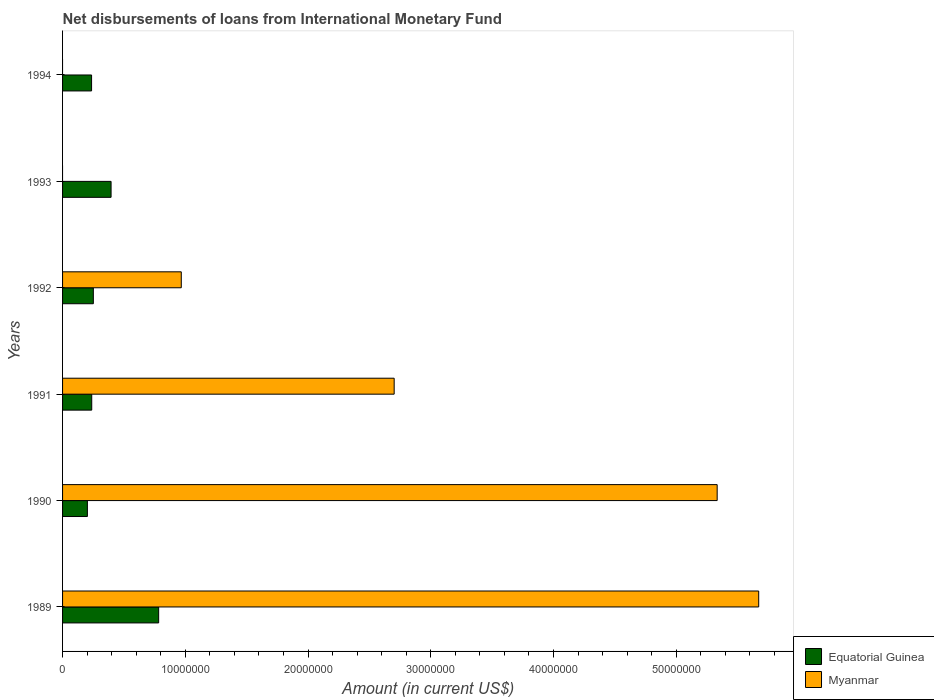How many different coloured bars are there?
Offer a terse response. 2. Are the number of bars per tick equal to the number of legend labels?
Your answer should be very brief. No. Are the number of bars on each tick of the Y-axis equal?
Offer a terse response. No. How many bars are there on the 3rd tick from the bottom?
Offer a very short reply. 2. What is the amount of loans disbursed in Myanmar in 1989?
Your answer should be very brief. 5.67e+07. Across all years, what is the maximum amount of loans disbursed in Myanmar?
Your response must be concise. 5.67e+07. Across all years, what is the minimum amount of loans disbursed in Myanmar?
Offer a terse response. 0. In which year was the amount of loans disbursed in Equatorial Guinea maximum?
Offer a very short reply. 1989. What is the total amount of loans disbursed in Equatorial Guinea in the graph?
Make the answer very short. 2.11e+07. What is the difference between the amount of loans disbursed in Equatorial Guinea in 1990 and that in 1991?
Offer a terse response. -3.53e+05. What is the difference between the amount of loans disbursed in Myanmar in 1994 and the amount of loans disbursed in Equatorial Guinea in 1989?
Your response must be concise. -7.83e+06. What is the average amount of loans disbursed in Equatorial Guinea per year?
Your answer should be compact. 3.51e+06. In the year 1992, what is the difference between the amount of loans disbursed in Myanmar and amount of loans disbursed in Equatorial Guinea?
Your response must be concise. 7.17e+06. What is the ratio of the amount of loans disbursed in Myanmar in 1990 to that in 1992?
Offer a very short reply. 5.51. Is the amount of loans disbursed in Equatorial Guinea in 1990 less than that in 1992?
Offer a very short reply. Yes. What is the difference between the highest and the second highest amount of loans disbursed in Equatorial Guinea?
Your answer should be very brief. 3.88e+06. What is the difference between the highest and the lowest amount of loans disbursed in Equatorial Guinea?
Offer a very short reply. 5.81e+06. Is the sum of the amount of loans disbursed in Equatorial Guinea in 1990 and 1994 greater than the maximum amount of loans disbursed in Myanmar across all years?
Give a very brief answer. No. How many years are there in the graph?
Your answer should be compact. 6. Does the graph contain grids?
Keep it short and to the point. No. How many legend labels are there?
Provide a succinct answer. 2. What is the title of the graph?
Provide a succinct answer. Net disbursements of loans from International Monetary Fund. What is the label or title of the Y-axis?
Make the answer very short. Years. What is the Amount (in current US$) of Equatorial Guinea in 1989?
Make the answer very short. 7.83e+06. What is the Amount (in current US$) in Myanmar in 1989?
Your answer should be compact. 5.67e+07. What is the Amount (in current US$) in Equatorial Guinea in 1990?
Provide a short and direct response. 2.02e+06. What is the Amount (in current US$) of Myanmar in 1990?
Ensure brevity in your answer.  5.33e+07. What is the Amount (in current US$) of Equatorial Guinea in 1991?
Provide a succinct answer. 2.38e+06. What is the Amount (in current US$) in Myanmar in 1991?
Your answer should be compact. 2.70e+07. What is the Amount (in current US$) in Equatorial Guinea in 1992?
Your response must be concise. 2.51e+06. What is the Amount (in current US$) of Myanmar in 1992?
Your answer should be compact. 9.67e+06. What is the Amount (in current US$) of Equatorial Guinea in 1993?
Keep it short and to the point. 3.95e+06. What is the Amount (in current US$) of Equatorial Guinea in 1994?
Give a very brief answer. 2.36e+06. Across all years, what is the maximum Amount (in current US$) of Equatorial Guinea?
Offer a terse response. 7.83e+06. Across all years, what is the maximum Amount (in current US$) in Myanmar?
Make the answer very short. 5.67e+07. Across all years, what is the minimum Amount (in current US$) in Equatorial Guinea?
Keep it short and to the point. 2.02e+06. Across all years, what is the minimum Amount (in current US$) in Myanmar?
Your response must be concise. 0. What is the total Amount (in current US$) in Equatorial Guinea in the graph?
Offer a terse response. 2.11e+07. What is the total Amount (in current US$) of Myanmar in the graph?
Your response must be concise. 1.47e+08. What is the difference between the Amount (in current US$) in Equatorial Guinea in 1989 and that in 1990?
Offer a very short reply. 5.81e+06. What is the difference between the Amount (in current US$) in Myanmar in 1989 and that in 1990?
Provide a short and direct response. 3.38e+06. What is the difference between the Amount (in current US$) of Equatorial Guinea in 1989 and that in 1991?
Offer a terse response. 5.45e+06. What is the difference between the Amount (in current US$) in Myanmar in 1989 and that in 1991?
Provide a succinct answer. 2.97e+07. What is the difference between the Amount (in current US$) of Equatorial Guinea in 1989 and that in 1992?
Provide a succinct answer. 5.32e+06. What is the difference between the Amount (in current US$) of Myanmar in 1989 and that in 1992?
Your answer should be very brief. 4.70e+07. What is the difference between the Amount (in current US$) in Equatorial Guinea in 1989 and that in 1993?
Offer a terse response. 3.88e+06. What is the difference between the Amount (in current US$) in Equatorial Guinea in 1989 and that in 1994?
Offer a very short reply. 5.47e+06. What is the difference between the Amount (in current US$) of Equatorial Guinea in 1990 and that in 1991?
Offer a very short reply. -3.53e+05. What is the difference between the Amount (in current US$) in Myanmar in 1990 and that in 1991?
Keep it short and to the point. 2.63e+07. What is the difference between the Amount (in current US$) in Equatorial Guinea in 1990 and that in 1992?
Your answer should be compact. -4.84e+05. What is the difference between the Amount (in current US$) in Myanmar in 1990 and that in 1992?
Ensure brevity in your answer.  4.37e+07. What is the difference between the Amount (in current US$) of Equatorial Guinea in 1990 and that in 1993?
Your response must be concise. -1.93e+06. What is the difference between the Amount (in current US$) in Equatorial Guinea in 1990 and that in 1994?
Provide a short and direct response. -3.40e+05. What is the difference between the Amount (in current US$) in Equatorial Guinea in 1991 and that in 1992?
Your answer should be very brief. -1.31e+05. What is the difference between the Amount (in current US$) of Myanmar in 1991 and that in 1992?
Offer a terse response. 1.73e+07. What is the difference between the Amount (in current US$) of Equatorial Guinea in 1991 and that in 1993?
Your answer should be very brief. -1.58e+06. What is the difference between the Amount (in current US$) in Equatorial Guinea in 1991 and that in 1994?
Offer a terse response. 1.27e+04. What is the difference between the Amount (in current US$) in Equatorial Guinea in 1992 and that in 1993?
Provide a succinct answer. -1.45e+06. What is the difference between the Amount (in current US$) of Equatorial Guinea in 1992 and that in 1994?
Make the answer very short. 1.44e+05. What is the difference between the Amount (in current US$) in Equatorial Guinea in 1993 and that in 1994?
Offer a very short reply. 1.59e+06. What is the difference between the Amount (in current US$) of Equatorial Guinea in 1989 and the Amount (in current US$) of Myanmar in 1990?
Provide a succinct answer. -4.55e+07. What is the difference between the Amount (in current US$) of Equatorial Guinea in 1989 and the Amount (in current US$) of Myanmar in 1991?
Your answer should be very brief. -1.92e+07. What is the difference between the Amount (in current US$) of Equatorial Guinea in 1989 and the Amount (in current US$) of Myanmar in 1992?
Your answer should be compact. -1.84e+06. What is the difference between the Amount (in current US$) of Equatorial Guinea in 1990 and the Amount (in current US$) of Myanmar in 1991?
Offer a terse response. -2.50e+07. What is the difference between the Amount (in current US$) in Equatorial Guinea in 1990 and the Amount (in current US$) in Myanmar in 1992?
Make the answer very short. -7.65e+06. What is the difference between the Amount (in current US$) of Equatorial Guinea in 1991 and the Amount (in current US$) of Myanmar in 1992?
Your answer should be compact. -7.30e+06. What is the average Amount (in current US$) of Equatorial Guinea per year?
Make the answer very short. 3.51e+06. What is the average Amount (in current US$) of Myanmar per year?
Offer a terse response. 2.45e+07. In the year 1989, what is the difference between the Amount (in current US$) in Equatorial Guinea and Amount (in current US$) in Myanmar?
Ensure brevity in your answer.  -4.89e+07. In the year 1990, what is the difference between the Amount (in current US$) of Equatorial Guinea and Amount (in current US$) of Myanmar?
Offer a very short reply. -5.13e+07. In the year 1991, what is the difference between the Amount (in current US$) in Equatorial Guinea and Amount (in current US$) in Myanmar?
Make the answer very short. -2.46e+07. In the year 1992, what is the difference between the Amount (in current US$) of Equatorial Guinea and Amount (in current US$) of Myanmar?
Ensure brevity in your answer.  -7.17e+06. What is the ratio of the Amount (in current US$) of Equatorial Guinea in 1989 to that in 1990?
Provide a short and direct response. 3.87. What is the ratio of the Amount (in current US$) of Myanmar in 1989 to that in 1990?
Your answer should be very brief. 1.06. What is the ratio of the Amount (in current US$) in Equatorial Guinea in 1989 to that in 1991?
Keep it short and to the point. 3.3. What is the ratio of the Amount (in current US$) of Myanmar in 1989 to that in 1991?
Offer a terse response. 2.1. What is the ratio of the Amount (in current US$) of Equatorial Guinea in 1989 to that in 1992?
Your answer should be compact. 3.12. What is the ratio of the Amount (in current US$) of Myanmar in 1989 to that in 1992?
Your answer should be very brief. 5.86. What is the ratio of the Amount (in current US$) in Equatorial Guinea in 1989 to that in 1993?
Offer a terse response. 1.98. What is the ratio of the Amount (in current US$) in Equatorial Guinea in 1989 to that in 1994?
Offer a terse response. 3.31. What is the ratio of the Amount (in current US$) in Equatorial Guinea in 1990 to that in 1991?
Ensure brevity in your answer.  0.85. What is the ratio of the Amount (in current US$) of Myanmar in 1990 to that in 1991?
Your answer should be compact. 1.97. What is the ratio of the Amount (in current US$) of Equatorial Guinea in 1990 to that in 1992?
Your response must be concise. 0.81. What is the ratio of the Amount (in current US$) in Myanmar in 1990 to that in 1992?
Your response must be concise. 5.51. What is the ratio of the Amount (in current US$) of Equatorial Guinea in 1990 to that in 1993?
Provide a short and direct response. 0.51. What is the ratio of the Amount (in current US$) of Equatorial Guinea in 1990 to that in 1994?
Offer a terse response. 0.86. What is the ratio of the Amount (in current US$) of Equatorial Guinea in 1991 to that in 1992?
Offer a very short reply. 0.95. What is the ratio of the Amount (in current US$) of Myanmar in 1991 to that in 1992?
Offer a very short reply. 2.79. What is the ratio of the Amount (in current US$) of Equatorial Guinea in 1991 to that in 1993?
Provide a short and direct response. 0.6. What is the ratio of the Amount (in current US$) in Equatorial Guinea in 1991 to that in 1994?
Offer a very short reply. 1.01. What is the ratio of the Amount (in current US$) in Equatorial Guinea in 1992 to that in 1993?
Your answer should be very brief. 0.63. What is the ratio of the Amount (in current US$) of Equatorial Guinea in 1992 to that in 1994?
Make the answer very short. 1.06. What is the ratio of the Amount (in current US$) of Equatorial Guinea in 1993 to that in 1994?
Ensure brevity in your answer.  1.67. What is the difference between the highest and the second highest Amount (in current US$) in Equatorial Guinea?
Offer a very short reply. 3.88e+06. What is the difference between the highest and the second highest Amount (in current US$) of Myanmar?
Offer a very short reply. 3.38e+06. What is the difference between the highest and the lowest Amount (in current US$) of Equatorial Guinea?
Ensure brevity in your answer.  5.81e+06. What is the difference between the highest and the lowest Amount (in current US$) of Myanmar?
Provide a succinct answer. 5.67e+07. 